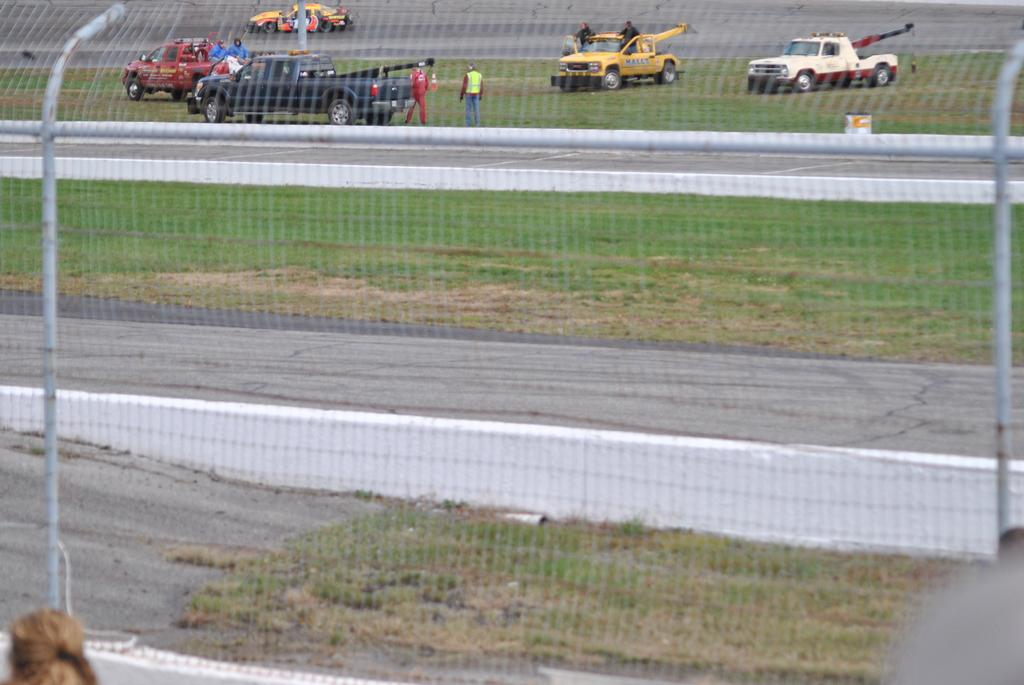What is the main object in the foreground of the image? There is a net with poles in the image. What can be seen in the background of the image? There are many vehicles and people in the background of the image. What type of surface is visible on the ground in the image? There is grass on the ground in the image. What type of flower can be seen growing in the net in the image? There are no flowers present in the image, and the net is not a suitable environment for growing flowers. 